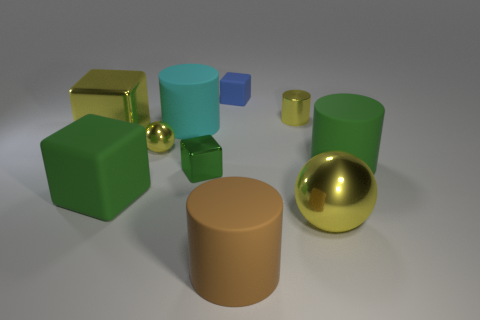Does the large shiny cube have the same color as the large metal thing that is in front of the small green object?
Give a very brief answer. Yes. There is another cube that is the same color as the tiny metallic cube; what is its material?
Provide a short and direct response. Rubber. What number of things are either tiny things left of the small green shiny cube or blue things?
Ensure brevity in your answer.  2. There is a large shiny ball that is right of the small yellow metal sphere; is it the same color as the large metal block?
Offer a terse response. Yes. What shape is the large green object left of the rubber thing right of the big yellow metallic sphere?
Provide a succinct answer. Cube. Is the number of big green objects that are left of the large yellow shiny sphere less than the number of yellow things to the right of the large cyan rubber cylinder?
Make the answer very short. Yes. The other green object that is the same shape as the tiny green thing is what size?
Ensure brevity in your answer.  Large. How many objects are either cubes that are left of the blue rubber block or large cylinders that are to the left of the large shiny sphere?
Keep it short and to the point. 5. Is the green rubber cube the same size as the green metal cube?
Your response must be concise. No. Is the number of red cubes greater than the number of big green matte cylinders?
Your answer should be very brief. No. 